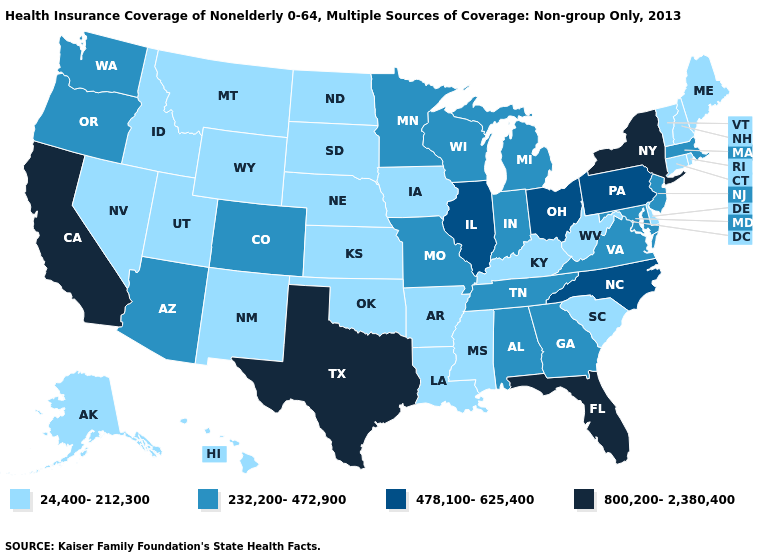What is the highest value in the USA?
Keep it brief. 800,200-2,380,400. Among the states that border Illinois , which have the highest value?
Answer briefly. Indiana, Missouri, Wisconsin. What is the value of Wisconsin?
Give a very brief answer. 232,200-472,900. What is the value of South Dakota?
Write a very short answer. 24,400-212,300. What is the value of Connecticut?
Concise answer only. 24,400-212,300. What is the value of Arkansas?
Be succinct. 24,400-212,300. Among the states that border Wyoming , which have the highest value?
Concise answer only. Colorado. Name the states that have a value in the range 232,200-472,900?
Give a very brief answer. Alabama, Arizona, Colorado, Georgia, Indiana, Maryland, Massachusetts, Michigan, Minnesota, Missouri, New Jersey, Oregon, Tennessee, Virginia, Washington, Wisconsin. Name the states that have a value in the range 232,200-472,900?
Keep it brief. Alabama, Arizona, Colorado, Georgia, Indiana, Maryland, Massachusetts, Michigan, Minnesota, Missouri, New Jersey, Oregon, Tennessee, Virginia, Washington, Wisconsin. What is the value of New Jersey?
Write a very short answer. 232,200-472,900. Which states have the lowest value in the USA?
Answer briefly. Alaska, Arkansas, Connecticut, Delaware, Hawaii, Idaho, Iowa, Kansas, Kentucky, Louisiana, Maine, Mississippi, Montana, Nebraska, Nevada, New Hampshire, New Mexico, North Dakota, Oklahoma, Rhode Island, South Carolina, South Dakota, Utah, Vermont, West Virginia, Wyoming. What is the lowest value in the MidWest?
Be succinct. 24,400-212,300. Name the states that have a value in the range 232,200-472,900?
Short answer required. Alabama, Arizona, Colorado, Georgia, Indiana, Maryland, Massachusetts, Michigan, Minnesota, Missouri, New Jersey, Oregon, Tennessee, Virginia, Washington, Wisconsin. What is the value of New Jersey?
Short answer required. 232,200-472,900. 